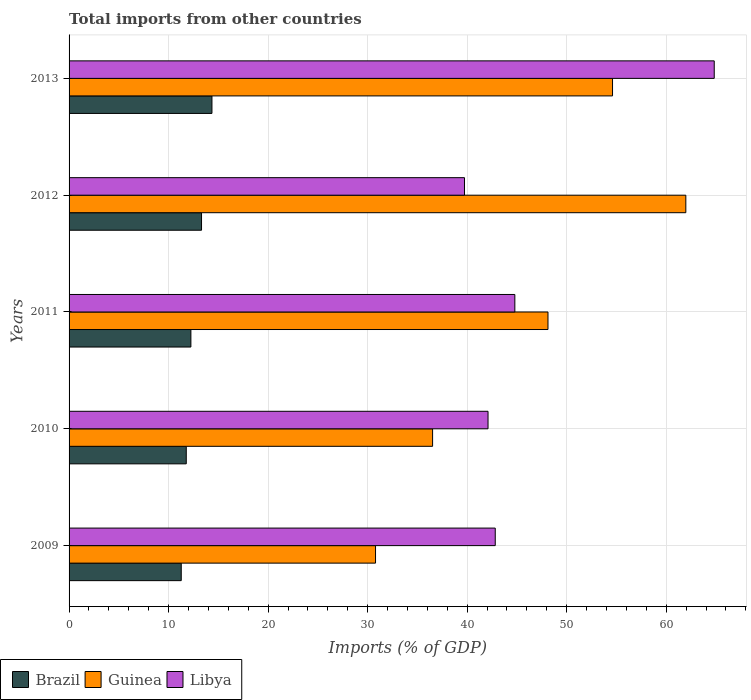How many groups of bars are there?
Your response must be concise. 5. Are the number of bars on each tick of the Y-axis equal?
Keep it short and to the point. Yes. How many bars are there on the 5th tick from the top?
Your answer should be very brief. 3. What is the label of the 2nd group of bars from the top?
Your answer should be very brief. 2012. What is the total imports in Libya in 2011?
Ensure brevity in your answer.  44.79. Across all years, what is the maximum total imports in Libya?
Your answer should be compact. 64.83. Across all years, what is the minimum total imports in Guinea?
Keep it short and to the point. 30.79. What is the total total imports in Libya in the graph?
Give a very brief answer. 234.27. What is the difference between the total imports in Brazil in 2010 and that in 2011?
Give a very brief answer. -0.46. What is the difference between the total imports in Brazil in 2009 and the total imports in Libya in 2011?
Your answer should be compact. -33.52. What is the average total imports in Libya per year?
Keep it short and to the point. 46.85. In the year 2011, what is the difference between the total imports in Brazil and total imports in Libya?
Provide a succinct answer. -32.55. In how many years, is the total imports in Libya greater than 4 %?
Your answer should be compact. 5. What is the ratio of the total imports in Brazil in 2009 to that in 2010?
Keep it short and to the point. 0.96. Is the total imports in Libya in 2009 less than that in 2011?
Ensure brevity in your answer.  Yes. Is the difference between the total imports in Brazil in 2009 and 2012 greater than the difference between the total imports in Libya in 2009 and 2012?
Provide a short and direct response. No. What is the difference between the highest and the second highest total imports in Brazil?
Keep it short and to the point. 1.05. What is the difference between the highest and the lowest total imports in Guinea?
Provide a short and direct response. 31.18. What does the 2nd bar from the top in 2013 represents?
Make the answer very short. Guinea. What does the 2nd bar from the bottom in 2010 represents?
Provide a succinct answer. Guinea. Are all the bars in the graph horizontal?
Your answer should be compact. Yes. What is the difference between two consecutive major ticks on the X-axis?
Keep it short and to the point. 10. Does the graph contain any zero values?
Provide a succinct answer. No. How many legend labels are there?
Ensure brevity in your answer.  3. What is the title of the graph?
Your answer should be very brief. Total imports from other countries. Does "Iraq" appear as one of the legend labels in the graph?
Ensure brevity in your answer.  No. What is the label or title of the X-axis?
Provide a short and direct response. Imports (% of GDP). What is the Imports (% of GDP) in Brazil in 2009?
Provide a succinct answer. 11.27. What is the Imports (% of GDP) of Guinea in 2009?
Ensure brevity in your answer.  30.79. What is the Imports (% of GDP) of Libya in 2009?
Provide a succinct answer. 42.82. What is the Imports (% of GDP) in Brazil in 2010?
Offer a very short reply. 11.78. What is the Imports (% of GDP) of Guinea in 2010?
Give a very brief answer. 36.53. What is the Imports (% of GDP) of Libya in 2010?
Give a very brief answer. 42.1. What is the Imports (% of GDP) of Brazil in 2011?
Your answer should be compact. 12.24. What is the Imports (% of GDP) of Guinea in 2011?
Provide a short and direct response. 48.12. What is the Imports (% of GDP) of Libya in 2011?
Provide a short and direct response. 44.79. What is the Imports (% of GDP) of Brazil in 2012?
Make the answer very short. 13.31. What is the Imports (% of GDP) of Guinea in 2012?
Ensure brevity in your answer.  61.97. What is the Imports (% of GDP) of Libya in 2012?
Make the answer very short. 39.73. What is the Imports (% of GDP) of Brazil in 2013?
Your answer should be very brief. 14.36. What is the Imports (% of GDP) of Guinea in 2013?
Keep it short and to the point. 54.61. What is the Imports (% of GDP) in Libya in 2013?
Make the answer very short. 64.83. Across all years, what is the maximum Imports (% of GDP) in Brazil?
Ensure brevity in your answer.  14.36. Across all years, what is the maximum Imports (% of GDP) in Guinea?
Provide a short and direct response. 61.97. Across all years, what is the maximum Imports (% of GDP) of Libya?
Your response must be concise. 64.83. Across all years, what is the minimum Imports (% of GDP) of Brazil?
Provide a short and direct response. 11.27. Across all years, what is the minimum Imports (% of GDP) of Guinea?
Your answer should be very brief. 30.79. Across all years, what is the minimum Imports (% of GDP) in Libya?
Your answer should be compact. 39.73. What is the total Imports (% of GDP) of Brazil in the graph?
Offer a terse response. 62.95. What is the total Imports (% of GDP) of Guinea in the graph?
Your answer should be very brief. 232.02. What is the total Imports (% of GDP) in Libya in the graph?
Your answer should be compact. 234.27. What is the difference between the Imports (% of GDP) of Brazil in 2009 and that in 2010?
Provide a short and direct response. -0.51. What is the difference between the Imports (% of GDP) in Guinea in 2009 and that in 2010?
Provide a succinct answer. -5.73. What is the difference between the Imports (% of GDP) in Libya in 2009 and that in 2010?
Keep it short and to the point. 0.72. What is the difference between the Imports (% of GDP) in Brazil in 2009 and that in 2011?
Keep it short and to the point. -0.97. What is the difference between the Imports (% of GDP) in Guinea in 2009 and that in 2011?
Your response must be concise. -17.33. What is the difference between the Imports (% of GDP) in Libya in 2009 and that in 2011?
Provide a succinct answer. -1.97. What is the difference between the Imports (% of GDP) of Brazil in 2009 and that in 2012?
Your response must be concise. -2.04. What is the difference between the Imports (% of GDP) in Guinea in 2009 and that in 2012?
Ensure brevity in your answer.  -31.18. What is the difference between the Imports (% of GDP) of Libya in 2009 and that in 2012?
Your answer should be compact. 3.09. What is the difference between the Imports (% of GDP) of Brazil in 2009 and that in 2013?
Your answer should be compact. -3.09. What is the difference between the Imports (% of GDP) in Guinea in 2009 and that in 2013?
Your answer should be very brief. -23.81. What is the difference between the Imports (% of GDP) in Libya in 2009 and that in 2013?
Your answer should be very brief. -22. What is the difference between the Imports (% of GDP) of Brazil in 2010 and that in 2011?
Offer a terse response. -0.46. What is the difference between the Imports (% of GDP) of Guinea in 2010 and that in 2011?
Offer a terse response. -11.59. What is the difference between the Imports (% of GDP) in Libya in 2010 and that in 2011?
Your answer should be very brief. -2.69. What is the difference between the Imports (% of GDP) in Brazil in 2010 and that in 2012?
Give a very brief answer. -1.53. What is the difference between the Imports (% of GDP) in Guinea in 2010 and that in 2012?
Offer a terse response. -25.44. What is the difference between the Imports (% of GDP) of Libya in 2010 and that in 2012?
Offer a terse response. 2.37. What is the difference between the Imports (% of GDP) in Brazil in 2010 and that in 2013?
Provide a succinct answer. -2.58. What is the difference between the Imports (% of GDP) in Guinea in 2010 and that in 2013?
Your answer should be very brief. -18.08. What is the difference between the Imports (% of GDP) in Libya in 2010 and that in 2013?
Give a very brief answer. -22.73. What is the difference between the Imports (% of GDP) of Brazil in 2011 and that in 2012?
Give a very brief answer. -1.07. What is the difference between the Imports (% of GDP) of Guinea in 2011 and that in 2012?
Your response must be concise. -13.85. What is the difference between the Imports (% of GDP) of Libya in 2011 and that in 2012?
Your response must be concise. 5.06. What is the difference between the Imports (% of GDP) in Brazil in 2011 and that in 2013?
Your answer should be compact. -2.12. What is the difference between the Imports (% of GDP) in Guinea in 2011 and that in 2013?
Offer a very short reply. -6.49. What is the difference between the Imports (% of GDP) of Libya in 2011 and that in 2013?
Offer a terse response. -20.03. What is the difference between the Imports (% of GDP) in Brazil in 2012 and that in 2013?
Your answer should be very brief. -1.05. What is the difference between the Imports (% of GDP) in Guinea in 2012 and that in 2013?
Offer a very short reply. 7.36. What is the difference between the Imports (% of GDP) in Libya in 2012 and that in 2013?
Provide a short and direct response. -25.1. What is the difference between the Imports (% of GDP) of Brazil in 2009 and the Imports (% of GDP) of Guinea in 2010?
Offer a very short reply. -25.26. What is the difference between the Imports (% of GDP) of Brazil in 2009 and the Imports (% of GDP) of Libya in 2010?
Offer a terse response. -30.83. What is the difference between the Imports (% of GDP) in Guinea in 2009 and the Imports (% of GDP) in Libya in 2010?
Ensure brevity in your answer.  -11.3. What is the difference between the Imports (% of GDP) of Brazil in 2009 and the Imports (% of GDP) of Guinea in 2011?
Offer a very short reply. -36.85. What is the difference between the Imports (% of GDP) in Brazil in 2009 and the Imports (% of GDP) in Libya in 2011?
Provide a short and direct response. -33.52. What is the difference between the Imports (% of GDP) in Guinea in 2009 and the Imports (% of GDP) in Libya in 2011?
Your response must be concise. -14. What is the difference between the Imports (% of GDP) in Brazil in 2009 and the Imports (% of GDP) in Guinea in 2012?
Your answer should be compact. -50.7. What is the difference between the Imports (% of GDP) in Brazil in 2009 and the Imports (% of GDP) in Libya in 2012?
Your answer should be compact. -28.46. What is the difference between the Imports (% of GDP) of Guinea in 2009 and the Imports (% of GDP) of Libya in 2012?
Give a very brief answer. -8.94. What is the difference between the Imports (% of GDP) of Brazil in 2009 and the Imports (% of GDP) of Guinea in 2013?
Offer a very short reply. -43.34. What is the difference between the Imports (% of GDP) in Brazil in 2009 and the Imports (% of GDP) in Libya in 2013?
Your response must be concise. -53.56. What is the difference between the Imports (% of GDP) in Guinea in 2009 and the Imports (% of GDP) in Libya in 2013?
Ensure brevity in your answer.  -34.03. What is the difference between the Imports (% of GDP) in Brazil in 2010 and the Imports (% of GDP) in Guinea in 2011?
Offer a very short reply. -36.35. What is the difference between the Imports (% of GDP) of Brazil in 2010 and the Imports (% of GDP) of Libya in 2011?
Keep it short and to the point. -33.02. What is the difference between the Imports (% of GDP) in Guinea in 2010 and the Imports (% of GDP) in Libya in 2011?
Offer a very short reply. -8.26. What is the difference between the Imports (% of GDP) in Brazil in 2010 and the Imports (% of GDP) in Guinea in 2012?
Give a very brief answer. -50.2. What is the difference between the Imports (% of GDP) of Brazil in 2010 and the Imports (% of GDP) of Libya in 2012?
Give a very brief answer. -27.95. What is the difference between the Imports (% of GDP) of Guinea in 2010 and the Imports (% of GDP) of Libya in 2012?
Give a very brief answer. -3.2. What is the difference between the Imports (% of GDP) of Brazil in 2010 and the Imports (% of GDP) of Guinea in 2013?
Your answer should be very brief. -42.83. What is the difference between the Imports (% of GDP) in Brazil in 2010 and the Imports (% of GDP) in Libya in 2013?
Your answer should be very brief. -53.05. What is the difference between the Imports (% of GDP) in Guinea in 2010 and the Imports (% of GDP) in Libya in 2013?
Provide a succinct answer. -28.3. What is the difference between the Imports (% of GDP) in Brazil in 2011 and the Imports (% of GDP) in Guinea in 2012?
Offer a terse response. -49.73. What is the difference between the Imports (% of GDP) in Brazil in 2011 and the Imports (% of GDP) in Libya in 2012?
Offer a very short reply. -27.49. What is the difference between the Imports (% of GDP) in Guinea in 2011 and the Imports (% of GDP) in Libya in 2012?
Your response must be concise. 8.39. What is the difference between the Imports (% of GDP) in Brazil in 2011 and the Imports (% of GDP) in Guinea in 2013?
Keep it short and to the point. -42.37. What is the difference between the Imports (% of GDP) of Brazil in 2011 and the Imports (% of GDP) of Libya in 2013?
Provide a short and direct response. -52.59. What is the difference between the Imports (% of GDP) of Guinea in 2011 and the Imports (% of GDP) of Libya in 2013?
Make the answer very short. -16.7. What is the difference between the Imports (% of GDP) in Brazil in 2012 and the Imports (% of GDP) in Guinea in 2013?
Make the answer very short. -41.3. What is the difference between the Imports (% of GDP) in Brazil in 2012 and the Imports (% of GDP) in Libya in 2013?
Keep it short and to the point. -51.52. What is the difference between the Imports (% of GDP) of Guinea in 2012 and the Imports (% of GDP) of Libya in 2013?
Keep it short and to the point. -2.85. What is the average Imports (% of GDP) in Brazil per year?
Offer a very short reply. 12.59. What is the average Imports (% of GDP) in Guinea per year?
Your answer should be very brief. 46.4. What is the average Imports (% of GDP) in Libya per year?
Make the answer very short. 46.85. In the year 2009, what is the difference between the Imports (% of GDP) in Brazil and Imports (% of GDP) in Guinea?
Keep it short and to the point. -19.52. In the year 2009, what is the difference between the Imports (% of GDP) in Brazil and Imports (% of GDP) in Libya?
Offer a very short reply. -31.55. In the year 2009, what is the difference between the Imports (% of GDP) in Guinea and Imports (% of GDP) in Libya?
Your answer should be compact. -12.03. In the year 2010, what is the difference between the Imports (% of GDP) in Brazil and Imports (% of GDP) in Guinea?
Your response must be concise. -24.75. In the year 2010, what is the difference between the Imports (% of GDP) of Brazil and Imports (% of GDP) of Libya?
Give a very brief answer. -30.32. In the year 2010, what is the difference between the Imports (% of GDP) of Guinea and Imports (% of GDP) of Libya?
Ensure brevity in your answer.  -5.57. In the year 2011, what is the difference between the Imports (% of GDP) in Brazil and Imports (% of GDP) in Guinea?
Your answer should be compact. -35.88. In the year 2011, what is the difference between the Imports (% of GDP) of Brazil and Imports (% of GDP) of Libya?
Your answer should be very brief. -32.55. In the year 2011, what is the difference between the Imports (% of GDP) of Guinea and Imports (% of GDP) of Libya?
Provide a succinct answer. 3.33. In the year 2012, what is the difference between the Imports (% of GDP) of Brazil and Imports (% of GDP) of Guinea?
Your response must be concise. -48.66. In the year 2012, what is the difference between the Imports (% of GDP) of Brazil and Imports (% of GDP) of Libya?
Keep it short and to the point. -26.42. In the year 2012, what is the difference between the Imports (% of GDP) of Guinea and Imports (% of GDP) of Libya?
Provide a short and direct response. 22.24. In the year 2013, what is the difference between the Imports (% of GDP) of Brazil and Imports (% of GDP) of Guinea?
Give a very brief answer. -40.25. In the year 2013, what is the difference between the Imports (% of GDP) in Brazil and Imports (% of GDP) in Libya?
Your answer should be compact. -50.47. In the year 2013, what is the difference between the Imports (% of GDP) in Guinea and Imports (% of GDP) in Libya?
Offer a terse response. -10.22. What is the ratio of the Imports (% of GDP) in Brazil in 2009 to that in 2010?
Your response must be concise. 0.96. What is the ratio of the Imports (% of GDP) in Guinea in 2009 to that in 2010?
Your response must be concise. 0.84. What is the ratio of the Imports (% of GDP) in Libya in 2009 to that in 2010?
Ensure brevity in your answer.  1.02. What is the ratio of the Imports (% of GDP) of Brazil in 2009 to that in 2011?
Your response must be concise. 0.92. What is the ratio of the Imports (% of GDP) of Guinea in 2009 to that in 2011?
Provide a succinct answer. 0.64. What is the ratio of the Imports (% of GDP) of Libya in 2009 to that in 2011?
Keep it short and to the point. 0.96. What is the ratio of the Imports (% of GDP) of Brazil in 2009 to that in 2012?
Ensure brevity in your answer.  0.85. What is the ratio of the Imports (% of GDP) in Guinea in 2009 to that in 2012?
Provide a short and direct response. 0.5. What is the ratio of the Imports (% of GDP) of Libya in 2009 to that in 2012?
Provide a succinct answer. 1.08. What is the ratio of the Imports (% of GDP) of Brazil in 2009 to that in 2013?
Your response must be concise. 0.79. What is the ratio of the Imports (% of GDP) in Guinea in 2009 to that in 2013?
Keep it short and to the point. 0.56. What is the ratio of the Imports (% of GDP) in Libya in 2009 to that in 2013?
Provide a short and direct response. 0.66. What is the ratio of the Imports (% of GDP) in Brazil in 2010 to that in 2011?
Offer a very short reply. 0.96. What is the ratio of the Imports (% of GDP) of Guinea in 2010 to that in 2011?
Offer a terse response. 0.76. What is the ratio of the Imports (% of GDP) in Libya in 2010 to that in 2011?
Keep it short and to the point. 0.94. What is the ratio of the Imports (% of GDP) in Brazil in 2010 to that in 2012?
Provide a succinct answer. 0.88. What is the ratio of the Imports (% of GDP) in Guinea in 2010 to that in 2012?
Your response must be concise. 0.59. What is the ratio of the Imports (% of GDP) of Libya in 2010 to that in 2012?
Your response must be concise. 1.06. What is the ratio of the Imports (% of GDP) of Brazil in 2010 to that in 2013?
Your answer should be compact. 0.82. What is the ratio of the Imports (% of GDP) in Guinea in 2010 to that in 2013?
Ensure brevity in your answer.  0.67. What is the ratio of the Imports (% of GDP) of Libya in 2010 to that in 2013?
Your answer should be compact. 0.65. What is the ratio of the Imports (% of GDP) in Brazil in 2011 to that in 2012?
Give a very brief answer. 0.92. What is the ratio of the Imports (% of GDP) of Guinea in 2011 to that in 2012?
Offer a terse response. 0.78. What is the ratio of the Imports (% of GDP) in Libya in 2011 to that in 2012?
Provide a succinct answer. 1.13. What is the ratio of the Imports (% of GDP) of Brazil in 2011 to that in 2013?
Offer a terse response. 0.85. What is the ratio of the Imports (% of GDP) of Guinea in 2011 to that in 2013?
Offer a very short reply. 0.88. What is the ratio of the Imports (% of GDP) of Libya in 2011 to that in 2013?
Ensure brevity in your answer.  0.69. What is the ratio of the Imports (% of GDP) of Brazil in 2012 to that in 2013?
Offer a terse response. 0.93. What is the ratio of the Imports (% of GDP) of Guinea in 2012 to that in 2013?
Provide a short and direct response. 1.13. What is the ratio of the Imports (% of GDP) in Libya in 2012 to that in 2013?
Offer a terse response. 0.61. What is the difference between the highest and the second highest Imports (% of GDP) in Brazil?
Give a very brief answer. 1.05. What is the difference between the highest and the second highest Imports (% of GDP) of Guinea?
Offer a very short reply. 7.36. What is the difference between the highest and the second highest Imports (% of GDP) in Libya?
Keep it short and to the point. 20.03. What is the difference between the highest and the lowest Imports (% of GDP) of Brazil?
Provide a short and direct response. 3.09. What is the difference between the highest and the lowest Imports (% of GDP) in Guinea?
Keep it short and to the point. 31.18. What is the difference between the highest and the lowest Imports (% of GDP) in Libya?
Provide a succinct answer. 25.1. 